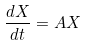Convert formula to latex. <formula><loc_0><loc_0><loc_500><loc_500>\frac { d X } { d t } = A X</formula> 